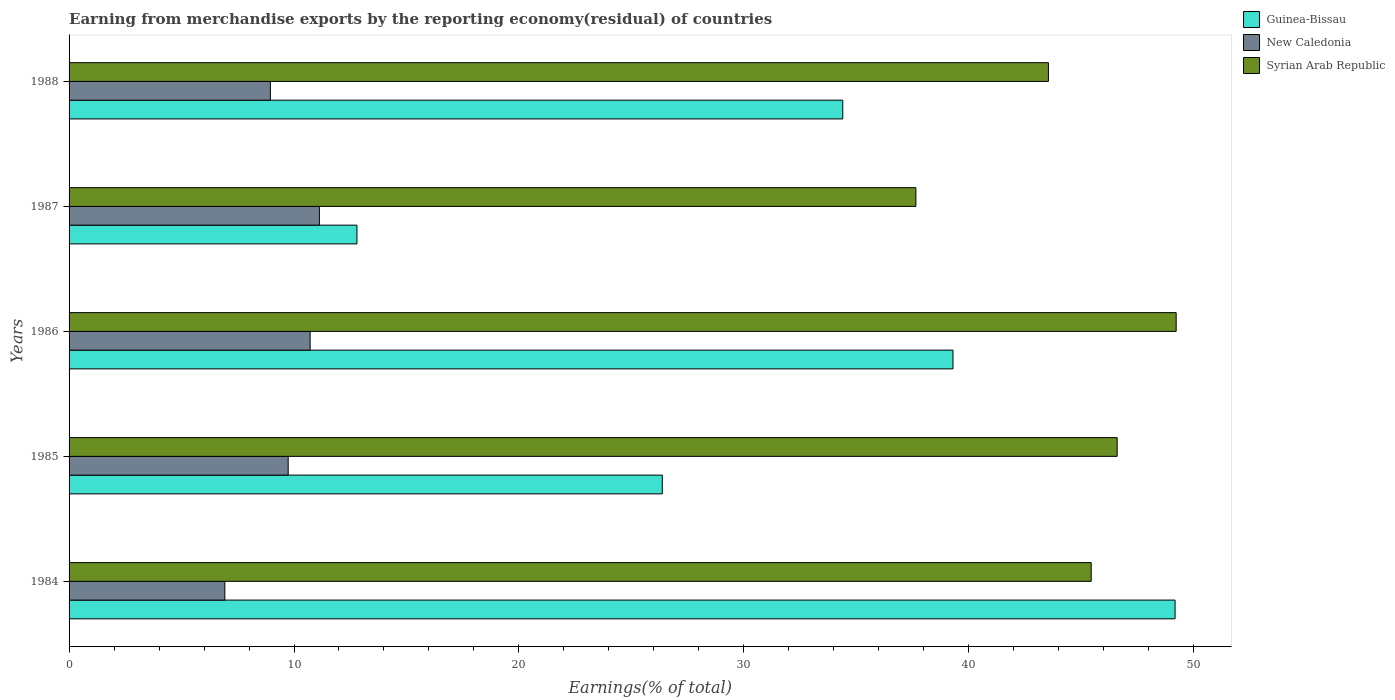How many groups of bars are there?
Keep it short and to the point. 5. Are the number of bars on each tick of the Y-axis equal?
Make the answer very short. Yes. How many bars are there on the 4th tick from the bottom?
Offer a terse response. 3. What is the label of the 1st group of bars from the top?
Give a very brief answer. 1988. In how many cases, is the number of bars for a given year not equal to the number of legend labels?
Give a very brief answer. 0. What is the percentage of amount earned from merchandise exports in New Caledonia in 1986?
Ensure brevity in your answer.  10.72. Across all years, what is the maximum percentage of amount earned from merchandise exports in Syrian Arab Republic?
Keep it short and to the point. 49.22. Across all years, what is the minimum percentage of amount earned from merchandise exports in Syrian Arab Republic?
Make the answer very short. 37.65. What is the total percentage of amount earned from merchandise exports in Syrian Arab Republic in the graph?
Offer a very short reply. 222.45. What is the difference between the percentage of amount earned from merchandise exports in New Caledonia in 1985 and that in 1988?
Your answer should be compact. 0.79. What is the difference between the percentage of amount earned from merchandise exports in Guinea-Bissau in 1986 and the percentage of amount earned from merchandise exports in New Caledonia in 1984?
Provide a short and direct response. 32.37. What is the average percentage of amount earned from merchandise exports in New Caledonia per year?
Offer a terse response. 9.49. In the year 1988, what is the difference between the percentage of amount earned from merchandise exports in Syrian Arab Republic and percentage of amount earned from merchandise exports in New Caledonia?
Provide a short and direct response. 34.59. What is the ratio of the percentage of amount earned from merchandise exports in Syrian Arab Republic in 1984 to that in 1986?
Your response must be concise. 0.92. Is the percentage of amount earned from merchandise exports in Syrian Arab Republic in 1984 less than that in 1986?
Give a very brief answer. Yes. What is the difference between the highest and the second highest percentage of amount earned from merchandise exports in New Caledonia?
Give a very brief answer. 0.41. What is the difference between the highest and the lowest percentage of amount earned from merchandise exports in Syrian Arab Republic?
Your answer should be very brief. 11.57. What does the 1st bar from the top in 1986 represents?
Offer a terse response. Syrian Arab Republic. What does the 2nd bar from the bottom in 1988 represents?
Make the answer very short. New Caledonia. Is it the case that in every year, the sum of the percentage of amount earned from merchandise exports in New Caledonia and percentage of amount earned from merchandise exports in Syrian Arab Republic is greater than the percentage of amount earned from merchandise exports in Guinea-Bissau?
Offer a very short reply. Yes. Are all the bars in the graph horizontal?
Give a very brief answer. Yes. How many years are there in the graph?
Keep it short and to the point. 5. What is the difference between two consecutive major ticks on the X-axis?
Keep it short and to the point. 10. Are the values on the major ticks of X-axis written in scientific E-notation?
Your answer should be compact. No. Does the graph contain any zero values?
Ensure brevity in your answer.  No. Does the graph contain grids?
Give a very brief answer. No. How many legend labels are there?
Your response must be concise. 3. What is the title of the graph?
Your answer should be compact. Earning from merchandise exports by the reporting economy(residual) of countries. What is the label or title of the X-axis?
Keep it short and to the point. Earnings(% of total). What is the Earnings(% of total) in Guinea-Bissau in 1984?
Provide a succinct answer. 49.17. What is the Earnings(% of total) of New Caledonia in 1984?
Your response must be concise. 6.93. What is the Earnings(% of total) of Syrian Arab Republic in 1984?
Your answer should be very brief. 45.44. What is the Earnings(% of total) in Guinea-Bissau in 1985?
Offer a very short reply. 26.37. What is the Earnings(% of total) in New Caledonia in 1985?
Make the answer very short. 9.74. What is the Earnings(% of total) in Syrian Arab Republic in 1985?
Provide a succinct answer. 46.6. What is the Earnings(% of total) of Guinea-Bissau in 1986?
Your answer should be compact. 39.3. What is the Earnings(% of total) in New Caledonia in 1986?
Provide a short and direct response. 10.72. What is the Earnings(% of total) in Syrian Arab Republic in 1986?
Keep it short and to the point. 49.22. What is the Earnings(% of total) in Guinea-Bissau in 1987?
Your answer should be compact. 12.8. What is the Earnings(% of total) of New Caledonia in 1987?
Provide a short and direct response. 11.13. What is the Earnings(% of total) of Syrian Arab Republic in 1987?
Ensure brevity in your answer.  37.65. What is the Earnings(% of total) of Guinea-Bissau in 1988?
Offer a terse response. 34.4. What is the Earnings(% of total) in New Caledonia in 1988?
Your answer should be very brief. 8.95. What is the Earnings(% of total) in Syrian Arab Republic in 1988?
Offer a terse response. 43.54. Across all years, what is the maximum Earnings(% of total) of Guinea-Bissau?
Keep it short and to the point. 49.17. Across all years, what is the maximum Earnings(% of total) in New Caledonia?
Offer a very short reply. 11.13. Across all years, what is the maximum Earnings(% of total) in Syrian Arab Republic?
Your answer should be compact. 49.22. Across all years, what is the minimum Earnings(% of total) of Guinea-Bissau?
Make the answer very short. 12.8. Across all years, what is the minimum Earnings(% of total) in New Caledonia?
Offer a terse response. 6.93. Across all years, what is the minimum Earnings(% of total) of Syrian Arab Republic?
Your response must be concise. 37.65. What is the total Earnings(% of total) in Guinea-Bissau in the graph?
Provide a short and direct response. 162.04. What is the total Earnings(% of total) of New Caledonia in the graph?
Offer a very short reply. 47.46. What is the total Earnings(% of total) in Syrian Arab Republic in the graph?
Your response must be concise. 222.45. What is the difference between the Earnings(% of total) in Guinea-Bissau in 1984 and that in 1985?
Your answer should be compact. 22.8. What is the difference between the Earnings(% of total) of New Caledonia in 1984 and that in 1985?
Offer a terse response. -2.82. What is the difference between the Earnings(% of total) of Syrian Arab Republic in 1984 and that in 1985?
Your response must be concise. -1.15. What is the difference between the Earnings(% of total) in Guinea-Bissau in 1984 and that in 1986?
Offer a terse response. 9.87. What is the difference between the Earnings(% of total) of New Caledonia in 1984 and that in 1986?
Provide a succinct answer. -3.79. What is the difference between the Earnings(% of total) of Syrian Arab Republic in 1984 and that in 1986?
Offer a very short reply. -3.78. What is the difference between the Earnings(% of total) of Guinea-Bissau in 1984 and that in 1987?
Provide a succinct answer. 36.37. What is the difference between the Earnings(% of total) of New Caledonia in 1984 and that in 1987?
Provide a succinct answer. -4.2. What is the difference between the Earnings(% of total) of Syrian Arab Republic in 1984 and that in 1987?
Your answer should be compact. 7.79. What is the difference between the Earnings(% of total) in Guinea-Bissau in 1984 and that in 1988?
Make the answer very short. 14.77. What is the difference between the Earnings(% of total) of New Caledonia in 1984 and that in 1988?
Offer a terse response. -2.02. What is the difference between the Earnings(% of total) of Syrian Arab Republic in 1984 and that in 1988?
Make the answer very short. 1.9. What is the difference between the Earnings(% of total) in Guinea-Bissau in 1985 and that in 1986?
Keep it short and to the point. -12.92. What is the difference between the Earnings(% of total) of New Caledonia in 1985 and that in 1986?
Provide a succinct answer. -0.97. What is the difference between the Earnings(% of total) of Syrian Arab Republic in 1985 and that in 1986?
Provide a short and direct response. -2.62. What is the difference between the Earnings(% of total) of Guinea-Bissau in 1985 and that in 1987?
Provide a short and direct response. 13.58. What is the difference between the Earnings(% of total) in New Caledonia in 1985 and that in 1987?
Provide a succinct answer. -1.39. What is the difference between the Earnings(% of total) in Syrian Arab Republic in 1985 and that in 1987?
Your answer should be very brief. 8.95. What is the difference between the Earnings(% of total) in Guinea-Bissau in 1985 and that in 1988?
Offer a terse response. -8.02. What is the difference between the Earnings(% of total) of New Caledonia in 1985 and that in 1988?
Give a very brief answer. 0.79. What is the difference between the Earnings(% of total) in Syrian Arab Republic in 1985 and that in 1988?
Offer a terse response. 3.06. What is the difference between the Earnings(% of total) of Guinea-Bissau in 1986 and that in 1987?
Provide a short and direct response. 26.5. What is the difference between the Earnings(% of total) in New Caledonia in 1986 and that in 1987?
Give a very brief answer. -0.41. What is the difference between the Earnings(% of total) of Syrian Arab Republic in 1986 and that in 1987?
Keep it short and to the point. 11.57. What is the difference between the Earnings(% of total) of Guinea-Bissau in 1986 and that in 1988?
Ensure brevity in your answer.  4.9. What is the difference between the Earnings(% of total) in New Caledonia in 1986 and that in 1988?
Your answer should be compact. 1.77. What is the difference between the Earnings(% of total) of Syrian Arab Republic in 1986 and that in 1988?
Your response must be concise. 5.68. What is the difference between the Earnings(% of total) of Guinea-Bissau in 1987 and that in 1988?
Make the answer very short. -21.6. What is the difference between the Earnings(% of total) of New Caledonia in 1987 and that in 1988?
Offer a very short reply. 2.18. What is the difference between the Earnings(% of total) in Syrian Arab Republic in 1987 and that in 1988?
Your answer should be compact. -5.89. What is the difference between the Earnings(% of total) in Guinea-Bissau in 1984 and the Earnings(% of total) in New Caledonia in 1985?
Make the answer very short. 39.43. What is the difference between the Earnings(% of total) in Guinea-Bissau in 1984 and the Earnings(% of total) in Syrian Arab Republic in 1985?
Offer a terse response. 2.57. What is the difference between the Earnings(% of total) of New Caledonia in 1984 and the Earnings(% of total) of Syrian Arab Republic in 1985?
Provide a short and direct response. -39.67. What is the difference between the Earnings(% of total) in Guinea-Bissau in 1984 and the Earnings(% of total) in New Caledonia in 1986?
Your response must be concise. 38.46. What is the difference between the Earnings(% of total) in Guinea-Bissau in 1984 and the Earnings(% of total) in Syrian Arab Republic in 1986?
Your answer should be compact. -0.05. What is the difference between the Earnings(% of total) of New Caledonia in 1984 and the Earnings(% of total) of Syrian Arab Republic in 1986?
Ensure brevity in your answer.  -42.3. What is the difference between the Earnings(% of total) of Guinea-Bissau in 1984 and the Earnings(% of total) of New Caledonia in 1987?
Provide a succinct answer. 38.04. What is the difference between the Earnings(% of total) of Guinea-Bissau in 1984 and the Earnings(% of total) of Syrian Arab Republic in 1987?
Offer a terse response. 11.52. What is the difference between the Earnings(% of total) in New Caledonia in 1984 and the Earnings(% of total) in Syrian Arab Republic in 1987?
Give a very brief answer. -30.72. What is the difference between the Earnings(% of total) of Guinea-Bissau in 1984 and the Earnings(% of total) of New Caledonia in 1988?
Your answer should be compact. 40.22. What is the difference between the Earnings(% of total) in Guinea-Bissau in 1984 and the Earnings(% of total) in Syrian Arab Republic in 1988?
Your answer should be very brief. 5.63. What is the difference between the Earnings(% of total) in New Caledonia in 1984 and the Earnings(% of total) in Syrian Arab Republic in 1988?
Offer a very short reply. -36.62. What is the difference between the Earnings(% of total) of Guinea-Bissau in 1985 and the Earnings(% of total) of New Caledonia in 1986?
Make the answer very short. 15.66. What is the difference between the Earnings(% of total) of Guinea-Bissau in 1985 and the Earnings(% of total) of Syrian Arab Republic in 1986?
Make the answer very short. -22.85. What is the difference between the Earnings(% of total) in New Caledonia in 1985 and the Earnings(% of total) in Syrian Arab Republic in 1986?
Provide a short and direct response. -39.48. What is the difference between the Earnings(% of total) of Guinea-Bissau in 1985 and the Earnings(% of total) of New Caledonia in 1987?
Give a very brief answer. 15.25. What is the difference between the Earnings(% of total) in Guinea-Bissau in 1985 and the Earnings(% of total) in Syrian Arab Republic in 1987?
Offer a terse response. -11.27. What is the difference between the Earnings(% of total) of New Caledonia in 1985 and the Earnings(% of total) of Syrian Arab Republic in 1987?
Provide a short and direct response. -27.91. What is the difference between the Earnings(% of total) in Guinea-Bissau in 1985 and the Earnings(% of total) in New Caledonia in 1988?
Give a very brief answer. 17.43. What is the difference between the Earnings(% of total) in Guinea-Bissau in 1985 and the Earnings(% of total) in Syrian Arab Republic in 1988?
Make the answer very short. -17.17. What is the difference between the Earnings(% of total) in New Caledonia in 1985 and the Earnings(% of total) in Syrian Arab Republic in 1988?
Ensure brevity in your answer.  -33.8. What is the difference between the Earnings(% of total) in Guinea-Bissau in 1986 and the Earnings(% of total) in New Caledonia in 1987?
Keep it short and to the point. 28.17. What is the difference between the Earnings(% of total) of Guinea-Bissau in 1986 and the Earnings(% of total) of Syrian Arab Republic in 1987?
Provide a short and direct response. 1.65. What is the difference between the Earnings(% of total) of New Caledonia in 1986 and the Earnings(% of total) of Syrian Arab Republic in 1987?
Your answer should be compact. -26.93. What is the difference between the Earnings(% of total) in Guinea-Bissau in 1986 and the Earnings(% of total) in New Caledonia in 1988?
Your answer should be very brief. 30.35. What is the difference between the Earnings(% of total) of Guinea-Bissau in 1986 and the Earnings(% of total) of Syrian Arab Republic in 1988?
Offer a terse response. -4.24. What is the difference between the Earnings(% of total) of New Caledonia in 1986 and the Earnings(% of total) of Syrian Arab Republic in 1988?
Your answer should be compact. -32.82. What is the difference between the Earnings(% of total) in Guinea-Bissau in 1987 and the Earnings(% of total) in New Caledonia in 1988?
Offer a very short reply. 3.85. What is the difference between the Earnings(% of total) in Guinea-Bissau in 1987 and the Earnings(% of total) in Syrian Arab Republic in 1988?
Provide a succinct answer. -30.74. What is the difference between the Earnings(% of total) in New Caledonia in 1987 and the Earnings(% of total) in Syrian Arab Republic in 1988?
Make the answer very short. -32.41. What is the average Earnings(% of total) of Guinea-Bissau per year?
Make the answer very short. 32.41. What is the average Earnings(% of total) in New Caledonia per year?
Provide a succinct answer. 9.49. What is the average Earnings(% of total) of Syrian Arab Republic per year?
Ensure brevity in your answer.  44.49. In the year 1984, what is the difference between the Earnings(% of total) in Guinea-Bissau and Earnings(% of total) in New Caledonia?
Your response must be concise. 42.25. In the year 1984, what is the difference between the Earnings(% of total) of Guinea-Bissau and Earnings(% of total) of Syrian Arab Republic?
Make the answer very short. 3.73. In the year 1984, what is the difference between the Earnings(% of total) in New Caledonia and Earnings(% of total) in Syrian Arab Republic?
Provide a succinct answer. -38.52. In the year 1985, what is the difference between the Earnings(% of total) of Guinea-Bissau and Earnings(% of total) of New Caledonia?
Your response must be concise. 16.63. In the year 1985, what is the difference between the Earnings(% of total) of Guinea-Bissau and Earnings(% of total) of Syrian Arab Republic?
Ensure brevity in your answer.  -20.22. In the year 1985, what is the difference between the Earnings(% of total) in New Caledonia and Earnings(% of total) in Syrian Arab Republic?
Provide a succinct answer. -36.86. In the year 1986, what is the difference between the Earnings(% of total) in Guinea-Bissau and Earnings(% of total) in New Caledonia?
Provide a short and direct response. 28.58. In the year 1986, what is the difference between the Earnings(% of total) in Guinea-Bissau and Earnings(% of total) in Syrian Arab Republic?
Make the answer very short. -9.92. In the year 1986, what is the difference between the Earnings(% of total) in New Caledonia and Earnings(% of total) in Syrian Arab Republic?
Your answer should be compact. -38.5. In the year 1987, what is the difference between the Earnings(% of total) in Guinea-Bissau and Earnings(% of total) in New Caledonia?
Your response must be concise. 1.67. In the year 1987, what is the difference between the Earnings(% of total) of Guinea-Bissau and Earnings(% of total) of Syrian Arab Republic?
Offer a very short reply. -24.85. In the year 1987, what is the difference between the Earnings(% of total) in New Caledonia and Earnings(% of total) in Syrian Arab Republic?
Ensure brevity in your answer.  -26.52. In the year 1988, what is the difference between the Earnings(% of total) of Guinea-Bissau and Earnings(% of total) of New Caledonia?
Your response must be concise. 25.45. In the year 1988, what is the difference between the Earnings(% of total) of Guinea-Bissau and Earnings(% of total) of Syrian Arab Republic?
Give a very brief answer. -9.14. In the year 1988, what is the difference between the Earnings(% of total) of New Caledonia and Earnings(% of total) of Syrian Arab Republic?
Give a very brief answer. -34.59. What is the ratio of the Earnings(% of total) of Guinea-Bissau in 1984 to that in 1985?
Provide a short and direct response. 1.86. What is the ratio of the Earnings(% of total) of New Caledonia in 1984 to that in 1985?
Your answer should be compact. 0.71. What is the ratio of the Earnings(% of total) in Syrian Arab Republic in 1984 to that in 1985?
Your answer should be compact. 0.98. What is the ratio of the Earnings(% of total) of Guinea-Bissau in 1984 to that in 1986?
Your answer should be compact. 1.25. What is the ratio of the Earnings(% of total) of New Caledonia in 1984 to that in 1986?
Make the answer very short. 0.65. What is the ratio of the Earnings(% of total) of Syrian Arab Republic in 1984 to that in 1986?
Your answer should be very brief. 0.92. What is the ratio of the Earnings(% of total) in Guinea-Bissau in 1984 to that in 1987?
Your response must be concise. 3.84. What is the ratio of the Earnings(% of total) in New Caledonia in 1984 to that in 1987?
Your response must be concise. 0.62. What is the ratio of the Earnings(% of total) of Syrian Arab Republic in 1984 to that in 1987?
Provide a succinct answer. 1.21. What is the ratio of the Earnings(% of total) in Guinea-Bissau in 1984 to that in 1988?
Your answer should be compact. 1.43. What is the ratio of the Earnings(% of total) in New Caledonia in 1984 to that in 1988?
Give a very brief answer. 0.77. What is the ratio of the Earnings(% of total) in Syrian Arab Republic in 1984 to that in 1988?
Give a very brief answer. 1.04. What is the ratio of the Earnings(% of total) of Guinea-Bissau in 1985 to that in 1986?
Offer a terse response. 0.67. What is the ratio of the Earnings(% of total) in New Caledonia in 1985 to that in 1986?
Provide a short and direct response. 0.91. What is the ratio of the Earnings(% of total) of Syrian Arab Republic in 1985 to that in 1986?
Your answer should be compact. 0.95. What is the ratio of the Earnings(% of total) of Guinea-Bissau in 1985 to that in 1987?
Your answer should be compact. 2.06. What is the ratio of the Earnings(% of total) in New Caledonia in 1985 to that in 1987?
Your answer should be compact. 0.88. What is the ratio of the Earnings(% of total) of Syrian Arab Republic in 1985 to that in 1987?
Your response must be concise. 1.24. What is the ratio of the Earnings(% of total) in Guinea-Bissau in 1985 to that in 1988?
Give a very brief answer. 0.77. What is the ratio of the Earnings(% of total) in New Caledonia in 1985 to that in 1988?
Make the answer very short. 1.09. What is the ratio of the Earnings(% of total) of Syrian Arab Republic in 1985 to that in 1988?
Offer a terse response. 1.07. What is the ratio of the Earnings(% of total) of Guinea-Bissau in 1986 to that in 1987?
Offer a terse response. 3.07. What is the ratio of the Earnings(% of total) of New Caledonia in 1986 to that in 1987?
Your answer should be very brief. 0.96. What is the ratio of the Earnings(% of total) of Syrian Arab Republic in 1986 to that in 1987?
Provide a succinct answer. 1.31. What is the ratio of the Earnings(% of total) of Guinea-Bissau in 1986 to that in 1988?
Provide a succinct answer. 1.14. What is the ratio of the Earnings(% of total) in New Caledonia in 1986 to that in 1988?
Provide a succinct answer. 1.2. What is the ratio of the Earnings(% of total) of Syrian Arab Republic in 1986 to that in 1988?
Provide a succinct answer. 1.13. What is the ratio of the Earnings(% of total) of Guinea-Bissau in 1987 to that in 1988?
Your response must be concise. 0.37. What is the ratio of the Earnings(% of total) of New Caledonia in 1987 to that in 1988?
Your answer should be compact. 1.24. What is the ratio of the Earnings(% of total) in Syrian Arab Republic in 1987 to that in 1988?
Ensure brevity in your answer.  0.86. What is the difference between the highest and the second highest Earnings(% of total) in Guinea-Bissau?
Ensure brevity in your answer.  9.87. What is the difference between the highest and the second highest Earnings(% of total) of New Caledonia?
Offer a very short reply. 0.41. What is the difference between the highest and the second highest Earnings(% of total) of Syrian Arab Republic?
Your answer should be very brief. 2.62. What is the difference between the highest and the lowest Earnings(% of total) in Guinea-Bissau?
Provide a short and direct response. 36.37. What is the difference between the highest and the lowest Earnings(% of total) in New Caledonia?
Your response must be concise. 4.2. What is the difference between the highest and the lowest Earnings(% of total) of Syrian Arab Republic?
Offer a very short reply. 11.57. 